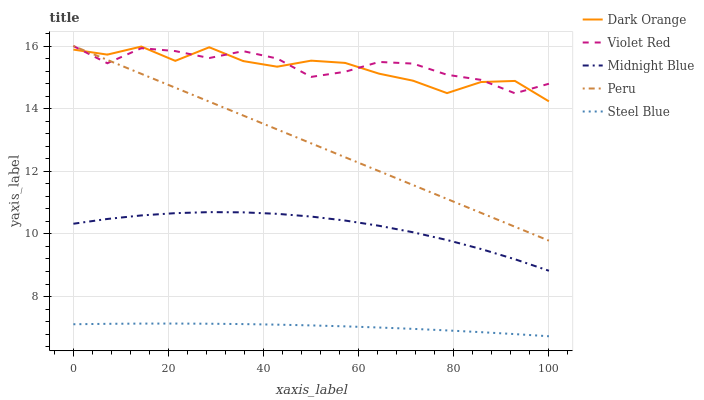Does Steel Blue have the minimum area under the curve?
Answer yes or no. Yes. Does Violet Red have the maximum area under the curve?
Answer yes or no. Yes. Does Midnight Blue have the minimum area under the curve?
Answer yes or no. No. Does Midnight Blue have the maximum area under the curve?
Answer yes or no. No. Is Peru the smoothest?
Answer yes or no. Yes. Is Dark Orange the roughest?
Answer yes or no. Yes. Is Violet Red the smoothest?
Answer yes or no. No. Is Violet Red the roughest?
Answer yes or no. No. Does Steel Blue have the lowest value?
Answer yes or no. Yes. Does Midnight Blue have the lowest value?
Answer yes or no. No. Does Peru have the highest value?
Answer yes or no. Yes. Does Midnight Blue have the highest value?
Answer yes or no. No. Is Steel Blue less than Violet Red?
Answer yes or no. Yes. Is Peru greater than Midnight Blue?
Answer yes or no. Yes. Does Dark Orange intersect Violet Red?
Answer yes or no. Yes. Is Dark Orange less than Violet Red?
Answer yes or no. No. Is Dark Orange greater than Violet Red?
Answer yes or no. No. Does Steel Blue intersect Violet Red?
Answer yes or no. No. 